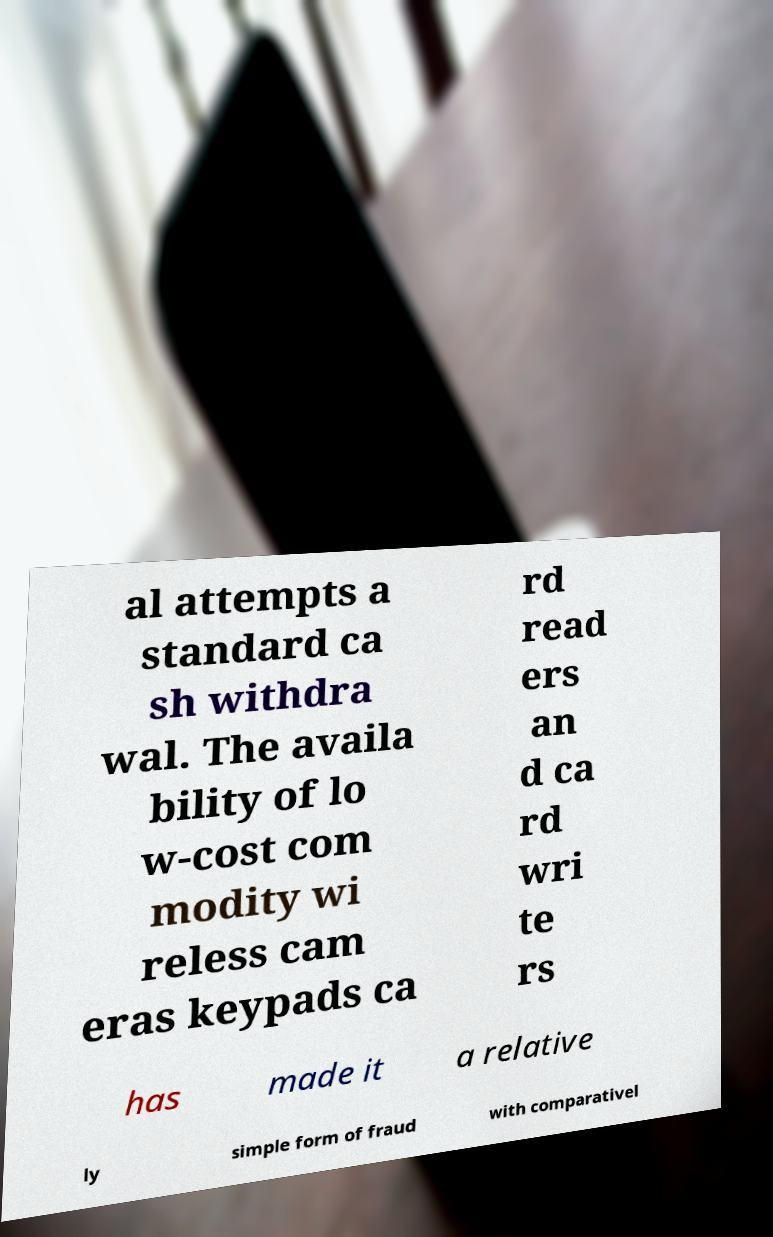Can you accurately transcribe the text from the provided image for me? al attempts a standard ca sh withdra wal. The availa bility of lo w-cost com modity wi reless cam eras keypads ca rd read ers an d ca rd wri te rs has made it a relative ly simple form of fraud with comparativel 